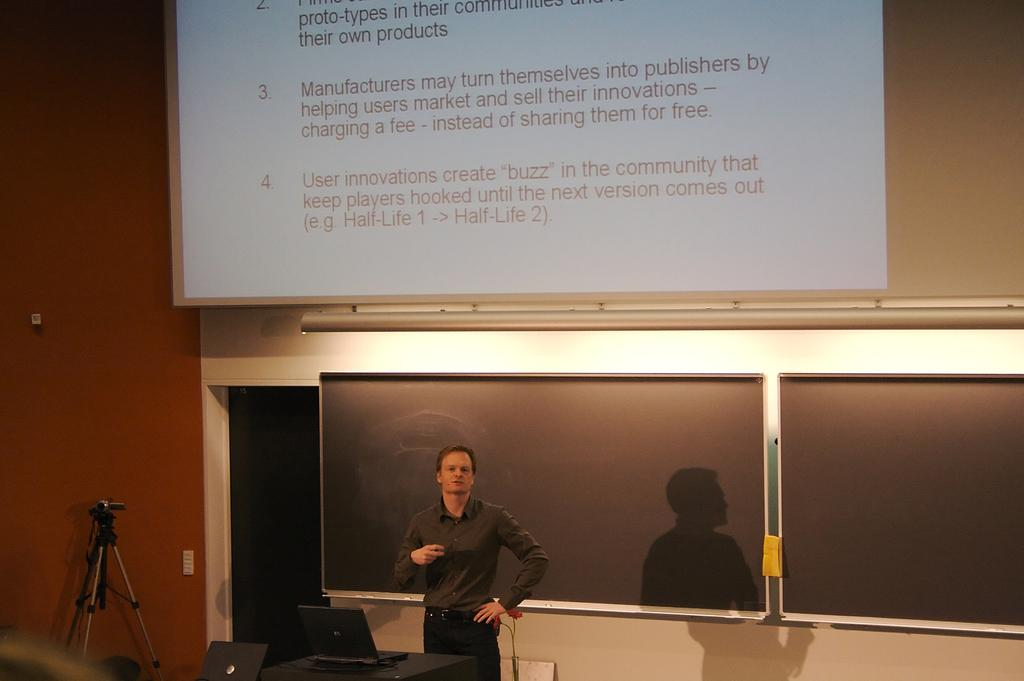What is the main subject in the image? There is a person standing in the image. What object can be seen on a table in the image? There is a laptop on a table in the image. What is located in the background of the image? There is a blackboard in the background of the image. What is visible on the screen in the image? The content of the screen cannot be determined from the provided facts. What is present on the left side of the image? There is a stand in the left side of the image. Can you see any visible veins on the person's neck in the image? There is no information about the person's veins in the provided facts, so it cannot be determined from the image. What type of collar is the person wearing in the image? There is no information about the person's clothing in the provided facts, so it cannot be determined from the image. 